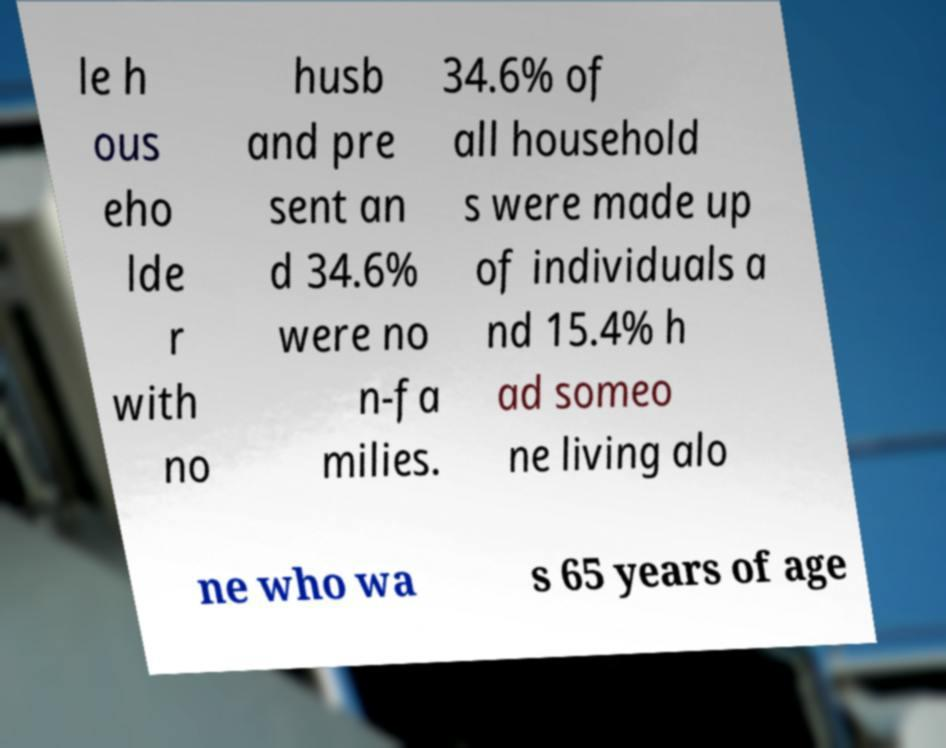Can you describe the kind of document shown in the image? The image seems to show a statistical report or a fact sheet that includes demographic data about household compositions. The font and layout suggest it's a formal document, perhaps from a governmental or research organization detailing census or survey outcomes. 